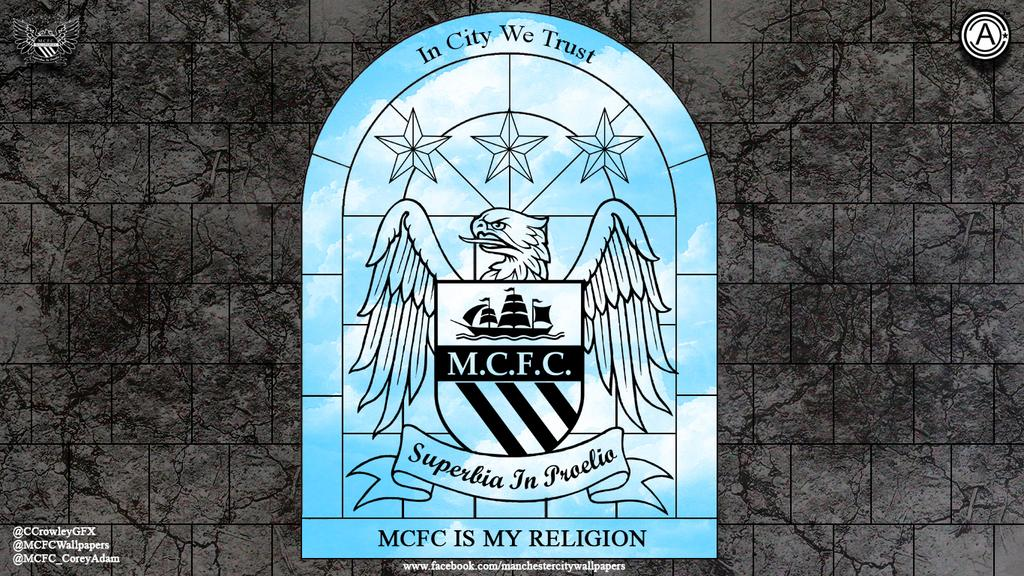<image>
Create a compact narrative representing the image presented. Symbol that has an eagle and the words In City We Trust on top. 